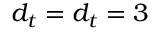<formula> <loc_0><loc_0><loc_500><loc_500>{ d _ { t } } = { d _ { t } } = 3</formula> 